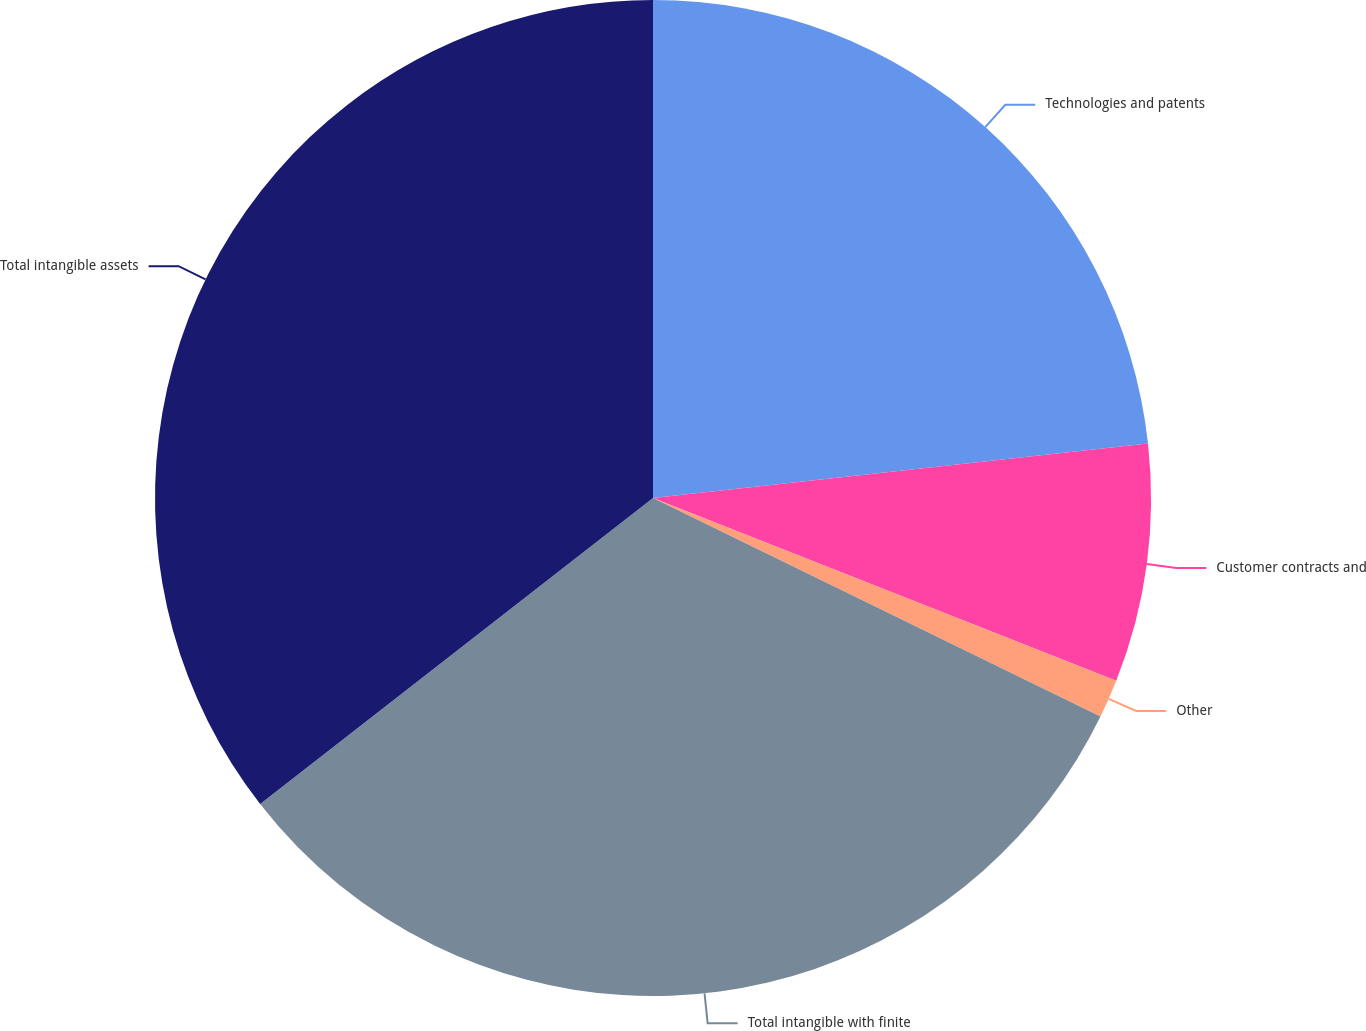Convert chart to OTSL. <chart><loc_0><loc_0><loc_500><loc_500><pie_chart><fcel>Technologies and patents<fcel>Customer contracts and<fcel>Other<fcel>Total intangible with finite<fcel>Total intangible assets<nl><fcel>23.25%<fcel>7.73%<fcel>1.25%<fcel>32.23%<fcel>35.53%<nl></chart> 